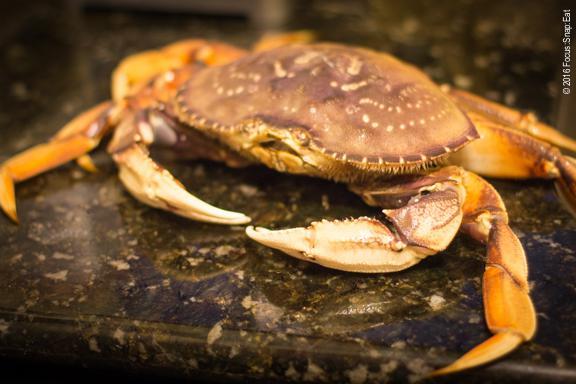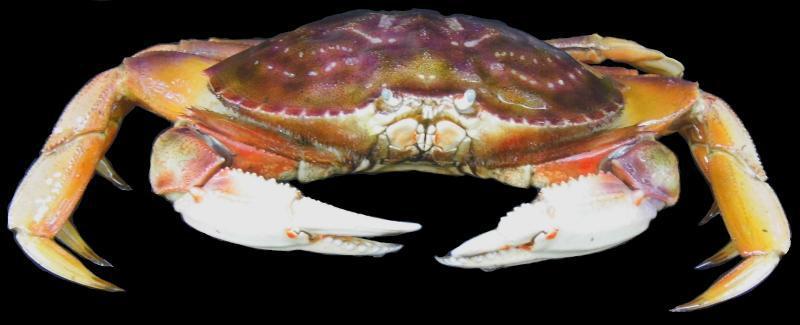The first image is the image on the left, the second image is the image on the right. Considering the images on both sides, is "One image shows a hand next to the top of an intact crab, and the other image shows two hands tearing a crab in two." valid? Answer yes or no. No. The first image is the image on the left, the second image is the image on the right. Evaluate the accuracy of this statement regarding the images: "One crab is being held by a human.". Is it true? Answer yes or no. No. 